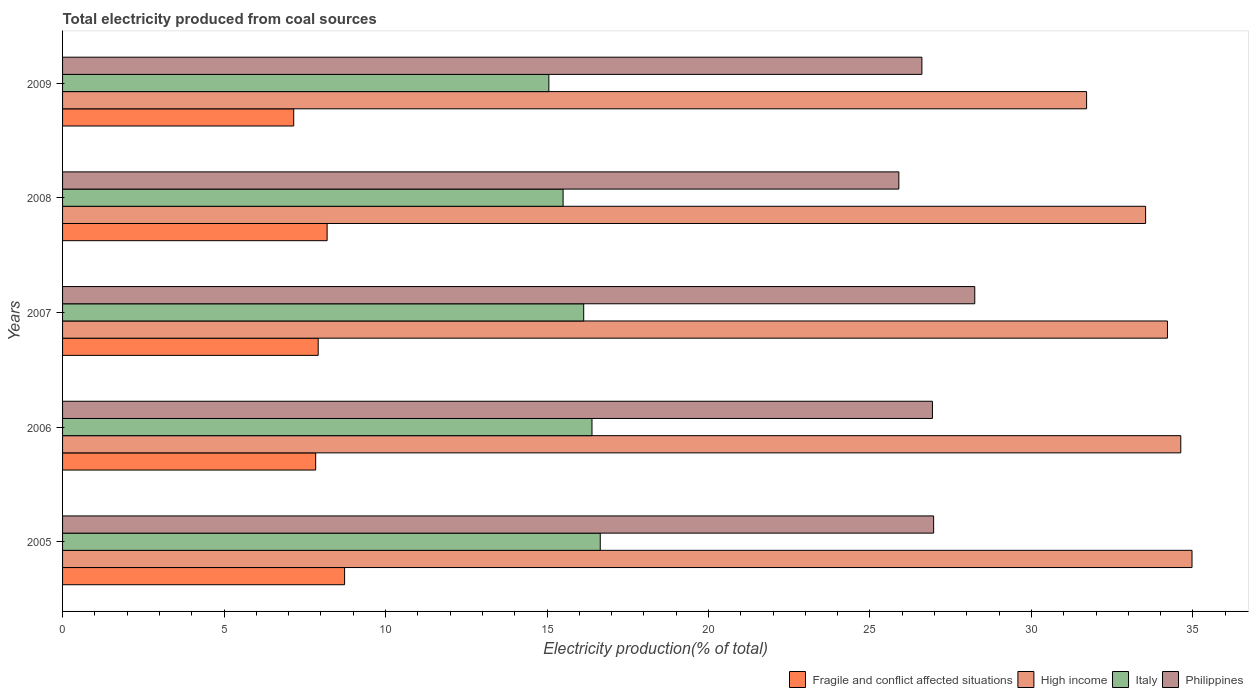How many different coloured bars are there?
Your answer should be very brief. 4. Are the number of bars per tick equal to the number of legend labels?
Provide a succinct answer. Yes. How many bars are there on the 4th tick from the top?
Your answer should be compact. 4. What is the label of the 3rd group of bars from the top?
Your response must be concise. 2007. In how many cases, is the number of bars for a given year not equal to the number of legend labels?
Make the answer very short. 0. What is the total electricity produced in Fragile and conflict affected situations in 2007?
Make the answer very short. 7.91. Across all years, what is the maximum total electricity produced in Philippines?
Your answer should be compact. 28.24. Across all years, what is the minimum total electricity produced in Fragile and conflict affected situations?
Provide a short and direct response. 7.16. What is the total total electricity produced in Fragile and conflict affected situations in the graph?
Make the answer very short. 39.83. What is the difference between the total electricity produced in Philippines in 2008 and that in 2009?
Keep it short and to the point. -0.71. What is the difference between the total electricity produced in Italy in 2006 and the total electricity produced in High income in 2005?
Provide a succinct answer. -18.58. What is the average total electricity produced in High income per year?
Your response must be concise. 33.81. In the year 2008, what is the difference between the total electricity produced in High income and total electricity produced in Italy?
Keep it short and to the point. 18.04. What is the ratio of the total electricity produced in High income in 2005 to that in 2007?
Offer a terse response. 1.02. What is the difference between the highest and the second highest total electricity produced in High income?
Provide a short and direct response. 0.35. What is the difference between the highest and the lowest total electricity produced in Italy?
Make the answer very short. 1.59. How many bars are there?
Give a very brief answer. 20. Are all the bars in the graph horizontal?
Your answer should be compact. Yes. How many years are there in the graph?
Make the answer very short. 5. Does the graph contain any zero values?
Offer a very short reply. No. Where does the legend appear in the graph?
Ensure brevity in your answer.  Bottom right. What is the title of the graph?
Your response must be concise. Total electricity produced from coal sources. Does "Samoa" appear as one of the legend labels in the graph?
Provide a succinct answer. No. What is the label or title of the Y-axis?
Your response must be concise. Years. What is the Electricity production(% of total) of Fragile and conflict affected situations in 2005?
Make the answer very short. 8.73. What is the Electricity production(% of total) of High income in 2005?
Your response must be concise. 34.97. What is the Electricity production(% of total) of Italy in 2005?
Give a very brief answer. 16.65. What is the Electricity production(% of total) in Philippines in 2005?
Your answer should be very brief. 26.97. What is the Electricity production(% of total) of Fragile and conflict affected situations in 2006?
Offer a terse response. 7.84. What is the Electricity production(% of total) of High income in 2006?
Offer a very short reply. 34.62. What is the Electricity production(% of total) in Italy in 2006?
Provide a short and direct response. 16.39. What is the Electricity production(% of total) in Philippines in 2006?
Make the answer very short. 26.93. What is the Electricity production(% of total) of Fragile and conflict affected situations in 2007?
Provide a short and direct response. 7.91. What is the Electricity production(% of total) in High income in 2007?
Give a very brief answer. 34.21. What is the Electricity production(% of total) of Italy in 2007?
Provide a short and direct response. 16.14. What is the Electricity production(% of total) in Philippines in 2007?
Ensure brevity in your answer.  28.24. What is the Electricity production(% of total) in Fragile and conflict affected situations in 2008?
Give a very brief answer. 8.19. What is the Electricity production(% of total) in High income in 2008?
Provide a succinct answer. 33.54. What is the Electricity production(% of total) of Italy in 2008?
Your response must be concise. 15.5. What is the Electricity production(% of total) of Philippines in 2008?
Your answer should be very brief. 25.89. What is the Electricity production(% of total) in Fragile and conflict affected situations in 2009?
Keep it short and to the point. 7.16. What is the Electricity production(% of total) in High income in 2009?
Make the answer very short. 31.71. What is the Electricity production(% of total) in Italy in 2009?
Make the answer very short. 15.06. What is the Electricity production(% of total) in Philippines in 2009?
Ensure brevity in your answer.  26.61. Across all years, what is the maximum Electricity production(% of total) in Fragile and conflict affected situations?
Offer a very short reply. 8.73. Across all years, what is the maximum Electricity production(% of total) in High income?
Make the answer very short. 34.97. Across all years, what is the maximum Electricity production(% of total) of Italy?
Make the answer very short. 16.65. Across all years, what is the maximum Electricity production(% of total) in Philippines?
Keep it short and to the point. 28.24. Across all years, what is the minimum Electricity production(% of total) in Fragile and conflict affected situations?
Your response must be concise. 7.16. Across all years, what is the minimum Electricity production(% of total) in High income?
Ensure brevity in your answer.  31.71. Across all years, what is the minimum Electricity production(% of total) in Italy?
Your answer should be very brief. 15.06. Across all years, what is the minimum Electricity production(% of total) in Philippines?
Your answer should be compact. 25.89. What is the total Electricity production(% of total) of Fragile and conflict affected situations in the graph?
Keep it short and to the point. 39.83. What is the total Electricity production(% of total) of High income in the graph?
Your answer should be compact. 169.05. What is the total Electricity production(% of total) in Italy in the graph?
Offer a very short reply. 79.73. What is the total Electricity production(% of total) in Philippines in the graph?
Make the answer very short. 134.65. What is the difference between the Electricity production(% of total) in Fragile and conflict affected situations in 2005 and that in 2006?
Give a very brief answer. 0.89. What is the difference between the Electricity production(% of total) in High income in 2005 and that in 2006?
Your answer should be compact. 0.35. What is the difference between the Electricity production(% of total) of Italy in 2005 and that in 2006?
Keep it short and to the point. 0.26. What is the difference between the Electricity production(% of total) of Philippines in 2005 and that in 2006?
Provide a succinct answer. 0.04. What is the difference between the Electricity production(% of total) of Fragile and conflict affected situations in 2005 and that in 2007?
Give a very brief answer. 0.82. What is the difference between the Electricity production(% of total) of High income in 2005 and that in 2007?
Give a very brief answer. 0.76. What is the difference between the Electricity production(% of total) of Italy in 2005 and that in 2007?
Provide a short and direct response. 0.51. What is the difference between the Electricity production(% of total) of Philippines in 2005 and that in 2007?
Keep it short and to the point. -1.27. What is the difference between the Electricity production(% of total) of Fragile and conflict affected situations in 2005 and that in 2008?
Give a very brief answer. 0.54. What is the difference between the Electricity production(% of total) of High income in 2005 and that in 2008?
Your response must be concise. 1.44. What is the difference between the Electricity production(% of total) in Italy in 2005 and that in 2008?
Ensure brevity in your answer.  1.15. What is the difference between the Electricity production(% of total) in Philippines in 2005 and that in 2008?
Give a very brief answer. 1.08. What is the difference between the Electricity production(% of total) in Fragile and conflict affected situations in 2005 and that in 2009?
Offer a terse response. 1.57. What is the difference between the Electricity production(% of total) in High income in 2005 and that in 2009?
Your response must be concise. 3.26. What is the difference between the Electricity production(% of total) of Italy in 2005 and that in 2009?
Ensure brevity in your answer.  1.59. What is the difference between the Electricity production(% of total) in Philippines in 2005 and that in 2009?
Your answer should be compact. 0.36. What is the difference between the Electricity production(% of total) of Fragile and conflict affected situations in 2006 and that in 2007?
Offer a very short reply. -0.08. What is the difference between the Electricity production(% of total) of High income in 2006 and that in 2007?
Offer a very short reply. 0.41. What is the difference between the Electricity production(% of total) of Italy in 2006 and that in 2007?
Ensure brevity in your answer.  0.26. What is the difference between the Electricity production(% of total) in Philippines in 2006 and that in 2007?
Offer a terse response. -1.31. What is the difference between the Electricity production(% of total) in Fragile and conflict affected situations in 2006 and that in 2008?
Offer a terse response. -0.35. What is the difference between the Electricity production(% of total) in High income in 2006 and that in 2008?
Provide a succinct answer. 1.09. What is the difference between the Electricity production(% of total) in Italy in 2006 and that in 2008?
Provide a short and direct response. 0.89. What is the difference between the Electricity production(% of total) in Philippines in 2006 and that in 2008?
Your answer should be very brief. 1.04. What is the difference between the Electricity production(% of total) in Fragile and conflict affected situations in 2006 and that in 2009?
Your answer should be very brief. 0.68. What is the difference between the Electricity production(% of total) in High income in 2006 and that in 2009?
Offer a terse response. 2.92. What is the difference between the Electricity production(% of total) in Italy in 2006 and that in 2009?
Keep it short and to the point. 1.33. What is the difference between the Electricity production(% of total) of Philippines in 2006 and that in 2009?
Offer a very short reply. 0.33. What is the difference between the Electricity production(% of total) in Fragile and conflict affected situations in 2007 and that in 2008?
Your answer should be compact. -0.28. What is the difference between the Electricity production(% of total) of High income in 2007 and that in 2008?
Provide a short and direct response. 0.68. What is the difference between the Electricity production(% of total) in Italy in 2007 and that in 2008?
Your response must be concise. 0.64. What is the difference between the Electricity production(% of total) in Philippines in 2007 and that in 2008?
Offer a terse response. 2.35. What is the difference between the Electricity production(% of total) of Fragile and conflict affected situations in 2007 and that in 2009?
Your answer should be very brief. 0.76. What is the difference between the Electricity production(% of total) in High income in 2007 and that in 2009?
Ensure brevity in your answer.  2.5. What is the difference between the Electricity production(% of total) of Italy in 2007 and that in 2009?
Your answer should be very brief. 1.08. What is the difference between the Electricity production(% of total) in Philippines in 2007 and that in 2009?
Provide a short and direct response. 1.64. What is the difference between the Electricity production(% of total) in Fragile and conflict affected situations in 2008 and that in 2009?
Provide a short and direct response. 1.03. What is the difference between the Electricity production(% of total) of High income in 2008 and that in 2009?
Make the answer very short. 1.83. What is the difference between the Electricity production(% of total) of Italy in 2008 and that in 2009?
Provide a succinct answer. 0.44. What is the difference between the Electricity production(% of total) of Philippines in 2008 and that in 2009?
Offer a terse response. -0.71. What is the difference between the Electricity production(% of total) of Fragile and conflict affected situations in 2005 and the Electricity production(% of total) of High income in 2006?
Make the answer very short. -25.89. What is the difference between the Electricity production(% of total) of Fragile and conflict affected situations in 2005 and the Electricity production(% of total) of Italy in 2006?
Your answer should be compact. -7.66. What is the difference between the Electricity production(% of total) of Fragile and conflict affected situations in 2005 and the Electricity production(% of total) of Philippines in 2006?
Your response must be concise. -18.2. What is the difference between the Electricity production(% of total) in High income in 2005 and the Electricity production(% of total) in Italy in 2006?
Provide a short and direct response. 18.58. What is the difference between the Electricity production(% of total) in High income in 2005 and the Electricity production(% of total) in Philippines in 2006?
Give a very brief answer. 8.04. What is the difference between the Electricity production(% of total) in Italy in 2005 and the Electricity production(% of total) in Philippines in 2006?
Your answer should be very brief. -10.29. What is the difference between the Electricity production(% of total) in Fragile and conflict affected situations in 2005 and the Electricity production(% of total) in High income in 2007?
Offer a very short reply. -25.48. What is the difference between the Electricity production(% of total) in Fragile and conflict affected situations in 2005 and the Electricity production(% of total) in Italy in 2007?
Provide a short and direct response. -7.4. What is the difference between the Electricity production(% of total) in Fragile and conflict affected situations in 2005 and the Electricity production(% of total) in Philippines in 2007?
Your answer should be very brief. -19.51. What is the difference between the Electricity production(% of total) in High income in 2005 and the Electricity production(% of total) in Italy in 2007?
Provide a short and direct response. 18.84. What is the difference between the Electricity production(% of total) of High income in 2005 and the Electricity production(% of total) of Philippines in 2007?
Offer a terse response. 6.73. What is the difference between the Electricity production(% of total) of Italy in 2005 and the Electricity production(% of total) of Philippines in 2007?
Ensure brevity in your answer.  -11.6. What is the difference between the Electricity production(% of total) of Fragile and conflict affected situations in 2005 and the Electricity production(% of total) of High income in 2008?
Provide a succinct answer. -24.8. What is the difference between the Electricity production(% of total) of Fragile and conflict affected situations in 2005 and the Electricity production(% of total) of Italy in 2008?
Your answer should be very brief. -6.77. What is the difference between the Electricity production(% of total) in Fragile and conflict affected situations in 2005 and the Electricity production(% of total) in Philippines in 2008?
Offer a very short reply. -17.16. What is the difference between the Electricity production(% of total) of High income in 2005 and the Electricity production(% of total) of Italy in 2008?
Your answer should be very brief. 19.47. What is the difference between the Electricity production(% of total) of High income in 2005 and the Electricity production(% of total) of Philippines in 2008?
Your response must be concise. 9.08. What is the difference between the Electricity production(% of total) in Italy in 2005 and the Electricity production(% of total) in Philippines in 2008?
Your response must be concise. -9.25. What is the difference between the Electricity production(% of total) of Fragile and conflict affected situations in 2005 and the Electricity production(% of total) of High income in 2009?
Your answer should be compact. -22.98. What is the difference between the Electricity production(% of total) of Fragile and conflict affected situations in 2005 and the Electricity production(% of total) of Italy in 2009?
Your response must be concise. -6.33. What is the difference between the Electricity production(% of total) of Fragile and conflict affected situations in 2005 and the Electricity production(% of total) of Philippines in 2009?
Offer a very short reply. -17.88. What is the difference between the Electricity production(% of total) of High income in 2005 and the Electricity production(% of total) of Italy in 2009?
Give a very brief answer. 19.91. What is the difference between the Electricity production(% of total) of High income in 2005 and the Electricity production(% of total) of Philippines in 2009?
Keep it short and to the point. 8.36. What is the difference between the Electricity production(% of total) of Italy in 2005 and the Electricity production(% of total) of Philippines in 2009?
Offer a terse response. -9.96. What is the difference between the Electricity production(% of total) in Fragile and conflict affected situations in 2006 and the Electricity production(% of total) in High income in 2007?
Offer a terse response. -26.37. What is the difference between the Electricity production(% of total) of Fragile and conflict affected situations in 2006 and the Electricity production(% of total) of Italy in 2007?
Provide a succinct answer. -8.3. What is the difference between the Electricity production(% of total) in Fragile and conflict affected situations in 2006 and the Electricity production(% of total) in Philippines in 2007?
Offer a very short reply. -20.41. What is the difference between the Electricity production(% of total) of High income in 2006 and the Electricity production(% of total) of Italy in 2007?
Give a very brief answer. 18.49. What is the difference between the Electricity production(% of total) of High income in 2006 and the Electricity production(% of total) of Philippines in 2007?
Keep it short and to the point. 6.38. What is the difference between the Electricity production(% of total) of Italy in 2006 and the Electricity production(% of total) of Philippines in 2007?
Keep it short and to the point. -11.85. What is the difference between the Electricity production(% of total) in Fragile and conflict affected situations in 2006 and the Electricity production(% of total) in High income in 2008?
Make the answer very short. -25.7. What is the difference between the Electricity production(% of total) in Fragile and conflict affected situations in 2006 and the Electricity production(% of total) in Italy in 2008?
Keep it short and to the point. -7.66. What is the difference between the Electricity production(% of total) of Fragile and conflict affected situations in 2006 and the Electricity production(% of total) of Philippines in 2008?
Make the answer very short. -18.06. What is the difference between the Electricity production(% of total) of High income in 2006 and the Electricity production(% of total) of Italy in 2008?
Provide a short and direct response. 19.13. What is the difference between the Electricity production(% of total) in High income in 2006 and the Electricity production(% of total) in Philippines in 2008?
Your answer should be compact. 8.73. What is the difference between the Electricity production(% of total) in Italy in 2006 and the Electricity production(% of total) in Philippines in 2008?
Keep it short and to the point. -9.5. What is the difference between the Electricity production(% of total) of Fragile and conflict affected situations in 2006 and the Electricity production(% of total) of High income in 2009?
Your answer should be very brief. -23.87. What is the difference between the Electricity production(% of total) of Fragile and conflict affected situations in 2006 and the Electricity production(% of total) of Italy in 2009?
Your answer should be very brief. -7.22. What is the difference between the Electricity production(% of total) of Fragile and conflict affected situations in 2006 and the Electricity production(% of total) of Philippines in 2009?
Your answer should be very brief. -18.77. What is the difference between the Electricity production(% of total) of High income in 2006 and the Electricity production(% of total) of Italy in 2009?
Ensure brevity in your answer.  19.57. What is the difference between the Electricity production(% of total) of High income in 2006 and the Electricity production(% of total) of Philippines in 2009?
Make the answer very short. 8.02. What is the difference between the Electricity production(% of total) of Italy in 2006 and the Electricity production(% of total) of Philippines in 2009?
Ensure brevity in your answer.  -10.22. What is the difference between the Electricity production(% of total) of Fragile and conflict affected situations in 2007 and the Electricity production(% of total) of High income in 2008?
Keep it short and to the point. -25.62. What is the difference between the Electricity production(% of total) of Fragile and conflict affected situations in 2007 and the Electricity production(% of total) of Italy in 2008?
Offer a terse response. -7.58. What is the difference between the Electricity production(% of total) of Fragile and conflict affected situations in 2007 and the Electricity production(% of total) of Philippines in 2008?
Offer a very short reply. -17.98. What is the difference between the Electricity production(% of total) of High income in 2007 and the Electricity production(% of total) of Italy in 2008?
Give a very brief answer. 18.71. What is the difference between the Electricity production(% of total) of High income in 2007 and the Electricity production(% of total) of Philippines in 2008?
Provide a short and direct response. 8.32. What is the difference between the Electricity production(% of total) in Italy in 2007 and the Electricity production(% of total) in Philippines in 2008?
Give a very brief answer. -9.76. What is the difference between the Electricity production(% of total) in Fragile and conflict affected situations in 2007 and the Electricity production(% of total) in High income in 2009?
Your answer should be compact. -23.79. What is the difference between the Electricity production(% of total) in Fragile and conflict affected situations in 2007 and the Electricity production(% of total) in Italy in 2009?
Provide a short and direct response. -7.14. What is the difference between the Electricity production(% of total) in Fragile and conflict affected situations in 2007 and the Electricity production(% of total) in Philippines in 2009?
Offer a very short reply. -18.69. What is the difference between the Electricity production(% of total) of High income in 2007 and the Electricity production(% of total) of Italy in 2009?
Your answer should be very brief. 19.15. What is the difference between the Electricity production(% of total) in High income in 2007 and the Electricity production(% of total) in Philippines in 2009?
Your answer should be very brief. 7.6. What is the difference between the Electricity production(% of total) of Italy in 2007 and the Electricity production(% of total) of Philippines in 2009?
Give a very brief answer. -10.47. What is the difference between the Electricity production(% of total) of Fragile and conflict affected situations in 2008 and the Electricity production(% of total) of High income in 2009?
Keep it short and to the point. -23.52. What is the difference between the Electricity production(% of total) of Fragile and conflict affected situations in 2008 and the Electricity production(% of total) of Italy in 2009?
Your answer should be compact. -6.87. What is the difference between the Electricity production(% of total) in Fragile and conflict affected situations in 2008 and the Electricity production(% of total) in Philippines in 2009?
Offer a terse response. -18.42. What is the difference between the Electricity production(% of total) of High income in 2008 and the Electricity production(% of total) of Italy in 2009?
Offer a terse response. 18.48. What is the difference between the Electricity production(% of total) in High income in 2008 and the Electricity production(% of total) in Philippines in 2009?
Provide a succinct answer. 6.93. What is the difference between the Electricity production(% of total) in Italy in 2008 and the Electricity production(% of total) in Philippines in 2009?
Give a very brief answer. -11.11. What is the average Electricity production(% of total) of Fragile and conflict affected situations per year?
Make the answer very short. 7.97. What is the average Electricity production(% of total) of High income per year?
Offer a very short reply. 33.81. What is the average Electricity production(% of total) in Italy per year?
Keep it short and to the point. 15.95. What is the average Electricity production(% of total) of Philippines per year?
Your answer should be very brief. 26.93. In the year 2005, what is the difference between the Electricity production(% of total) in Fragile and conflict affected situations and Electricity production(% of total) in High income?
Give a very brief answer. -26.24. In the year 2005, what is the difference between the Electricity production(% of total) in Fragile and conflict affected situations and Electricity production(% of total) in Italy?
Give a very brief answer. -7.92. In the year 2005, what is the difference between the Electricity production(% of total) in Fragile and conflict affected situations and Electricity production(% of total) in Philippines?
Provide a succinct answer. -18.24. In the year 2005, what is the difference between the Electricity production(% of total) of High income and Electricity production(% of total) of Italy?
Provide a short and direct response. 18.32. In the year 2005, what is the difference between the Electricity production(% of total) in High income and Electricity production(% of total) in Philippines?
Offer a very short reply. 8. In the year 2005, what is the difference between the Electricity production(% of total) in Italy and Electricity production(% of total) in Philippines?
Provide a succinct answer. -10.32. In the year 2006, what is the difference between the Electricity production(% of total) in Fragile and conflict affected situations and Electricity production(% of total) in High income?
Offer a terse response. -26.79. In the year 2006, what is the difference between the Electricity production(% of total) of Fragile and conflict affected situations and Electricity production(% of total) of Italy?
Your answer should be very brief. -8.55. In the year 2006, what is the difference between the Electricity production(% of total) in Fragile and conflict affected situations and Electricity production(% of total) in Philippines?
Provide a short and direct response. -19.1. In the year 2006, what is the difference between the Electricity production(% of total) of High income and Electricity production(% of total) of Italy?
Your answer should be very brief. 18.23. In the year 2006, what is the difference between the Electricity production(% of total) of High income and Electricity production(% of total) of Philippines?
Your answer should be compact. 7.69. In the year 2006, what is the difference between the Electricity production(% of total) in Italy and Electricity production(% of total) in Philippines?
Your answer should be compact. -10.54. In the year 2007, what is the difference between the Electricity production(% of total) in Fragile and conflict affected situations and Electricity production(% of total) in High income?
Offer a terse response. -26.3. In the year 2007, what is the difference between the Electricity production(% of total) of Fragile and conflict affected situations and Electricity production(% of total) of Italy?
Provide a succinct answer. -8.22. In the year 2007, what is the difference between the Electricity production(% of total) in Fragile and conflict affected situations and Electricity production(% of total) in Philippines?
Give a very brief answer. -20.33. In the year 2007, what is the difference between the Electricity production(% of total) of High income and Electricity production(% of total) of Italy?
Your answer should be compact. 18.07. In the year 2007, what is the difference between the Electricity production(% of total) of High income and Electricity production(% of total) of Philippines?
Your answer should be very brief. 5.97. In the year 2007, what is the difference between the Electricity production(% of total) of Italy and Electricity production(% of total) of Philippines?
Keep it short and to the point. -12.11. In the year 2008, what is the difference between the Electricity production(% of total) of Fragile and conflict affected situations and Electricity production(% of total) of High income?
Make the answer very short. -25.34. In the year 2008, what is the difference between the Electricity production(% of total) in Fragile and conflict affected situations and Electricity production(% of total) in Italy?
Give a very brief answer. -7.31. In the year 2008, what is the difference between the Electricity production(% of total) in Fragile and conflict affected situations and Electricity production(% of total) in Philippines?
Offer a terse response. -17.7. In the year 2008, what is the difference between the Electricity production(% of total) of High income and Electricity production(% of total) of Italy?
Ensure brevity in your answer.  18.04. In the year 2008, what is the difference between the Electricity production(% of total) in High income and Electricity production(% of total) in Philippines?
Ensure brevity in your answer.  7.64. In the year 2008, what is the difference between the Electricity production(% of total) in Italy and Electricity production(% of total) in Philippines?
Keep it short and to the point. -10.4. In the year 2009, what is the difference between the Electricity production(% of total) of Fragile and conflict affected situations and Electricity production(% of total) of High income?
Make the answer very short. -24.55. In the year 2009, what is the difference between the Electricity production(% of total) in Fragile and conflict affected situations and Electricity production(% of total) in Italy?
Make the answer very short. -7.9. In the year 2009, what is the difference between the Electricity production(% of total) in Fragile and conflict affected situations and Electricity production(% of total) in Philippines?
Offer a very short reply. -19.45. In the year 2009, what is the difference between the Electricity production(% of total) in High income and Electricity production(% of total) in Italy?
Provide a short and direct response. 16.65. In the year 2009, what is the difference between the Electricity production(% of total) of High income and Electricity production(% of total) of Philippines?
Your response must be concise. 5.1. In the year 2009, what is the difference between the Electricity production(% of total) in Italy and Electricity production(% of total) in Philippines?
Offer a very short reply. -11.55. What is the ratio of the Electricity production(% of total) of Fragile and conflict affected situations in 2005 to that in 2006?
Provide a succinct answer. 1.11. What is the ratio of the Electricity production(% of total) of High income in 2005 to that in 2006?
Your response must be concise. 1.01. What is the ratio of the Electricity production(% of total) in Italy in 2005 to that in 2006?
Make the answer very short. 1.02. What is the ratio of the Electricity production(% of total) of Fragile and conflict affected situations in 2005 to that in 2007?
Your answer should be very brief. 1.1. What is the ratio of the Electricity production(% of total) of High income in 2005 to that in 2007?
Keep it short and to the point. 1.02. What is the ratio of the Electricity production(% of total) in Italy in 2005 to that in 2007?
Your answer should be compact. 1.03. What is the ratio of the Electricity production(% of total) in Philippines in 2005 to that in 2007?
Provide a short and direct response. 0.95. What is the ratio of the Electricity production(% of total) in Fragile and conflict affected situations in 2005 to that in 2008?
Offer a very short reply. 1.07. What is the ratio of the Electricity production(% of total) of High income in 2005 to that in 2008?
Offer a very short reply. 1.04. What is the ratio of the Electricity production(% of total) in Italy in 2005 to that in 2008?
Offer a terse response. 1.07. What is the ratio of the Electricity production(% of total) in Philippines in 2005 to that in 2008?
Offer a terse response. 1.04. What is the ratio of the Electricity production(% of total) in Fragile and conflict affected situations in 2005 to that in 2009?
Provide a succinct answer. 1.22. What is the ratio of the Electricity production(% of total) in High income in 2005 to that in 2009?
Provide a short and direct response. 1.1. What is the ratio of the Electricity production(% of total) in Italy in 2005 to that in 2009?
Provide a short and direct response. 1.11. What is the ratio of the Electricity production(% of total) in Philippines in 2005 to that in 2009?
Offer a terse response. 1.01. What is the ratio of the Electricity production(% of total) of Fragile and conflict affected situations in 2006 to that in 2007?
Ensure brevity in your answer.  0.99. What is the ratio of the Electricity production(% of total) in High income in 2006 to that in 2007?
Offer a terse response. 1.01. What is the ratio of the Electricity production(% of total) of Italy in 2006 to that in 2007?
Make the answer very short. 1.02. What is the ratio of the Electricity production(% of total) of Philippines in 2006 to that in 2007?
Ensure brevity in your answer.  0.95. What is the ratio of the Electricity production(% of total) in Fragile and conflict affected situations in 2006 to that in 2008?
Give a very brief answer. 0.96. What is the ratio of the Electricity production(% of total) of High income in 2006 to that in 2008?
Keep it short and to the point. 1.03. What is the ratio of the Electricity production(% of total) of Italy in 2006 to that in 2008?
Your answer should be very brief. 1.06. What is the ratio of the Electricity production(% of total) of Philippines in 2006 to that in 2008?
Provide a short and direct response. 1.04. What is the ratio of the Electricity production(% of total) in Fragile and conflict affected situations in 2006 to that in 2009?
Keep it short and to the point. 1.1. What is the ratio of the Electricity production(% of total) of High income in 2006 to that in 2009?
Your answer should be very brief. 1.09. What is the ratio of the Electricity production(% of total) in Italy in 2006 to that in 2009?
Offer a very short reply. 1.09. What is the ratio of the Electricity production(% of total) in Philippines in 2006 to that in 2009?
Give a very brief answer. 1.01. What is the ratio of the Electricity production(% of total) of Fragile and conflict affected situations in 2007 to that in 2008?
Your response must be concise. 0.97. What is the ratio of the Electricity production(% of total) in High income in 2007 to that in 2008?
Give a very brief answer. 1.02. What is the ratio of the Electricity production(% of total) of Italy in 2007 to that in 2008?
Your response must be concise. 1.04. What is the ratio of the Electricity production(% of total) of Philippines in 2007 to that in 2008?
Offer a very short reply. 1.09. What is the ratio of the Electricity production(% of total) of Fragile and conflict affected situations in 2007 to that in 2009?
Make the answer very short. 1.11. What is the ratio of the Electricity production(% of total) of High income in 2007 to that in 2009?
Your response must be concise. 1.08. What is the ratio of the Electricity production(% of total) in Italy in 2007 to that in 2009?
Your response must be concise. 1.07. What is the ratio of the Electricity production(% of total) in Philippines in 2007 to that in 2009?
Provide a short and direct response. 1.06. What is the ratio of the Electricity production(% of total) in Fragile and conflict affected situations in 2008 to that in 2009?
Make the answer very short. 1.14. What is the ratio of the Electricity production(% of total) of High income in 2008 to that in 2009?
Provide a short and direct response. 1.06. What is the ratio of the Electricity production(% of total) of Italy in 2008 to that in 2009?
Give a very brief answer. 1.03. What is the ratio of the Electricity production(% of total) of Philippines in 2008 to that in 2009?
Your response must be concise. 0.97. What is the difference between the highest and the second highest Electricity production(% of total) in Fragile and conflict affected situations?
Provide a short and direct response. 0.54. What is the difference between the highest and the second highest Electricity production(% of total) of High income?
Your response must be concise. 0.35. What is the difference between the highest and the second highest Electricity production(% of total) in Italy?
Keep it short and to the point. 0.26. What is the difference between the highest and the second highest Electricity production(% of total) of Philippines?
Offer a very short reply. 1.27. What is the difference between the highest and the lowest Electricity production(% of total) of Fragile and conflict affected situations?
Your answer should be very brief. 1.57. What is the difference between the highest and the lowest Electricity production(% of total) in High income?
Make the answer very short. 3.26. What is the difference between the highest and the lowest Electricity production(% of total) in Italy?
Provide a short and direct response. 1.59. What is the difference between the highest and the lowest Electricity production(% of total) in Philippines?
Provide a succinct answer. 2.35. 